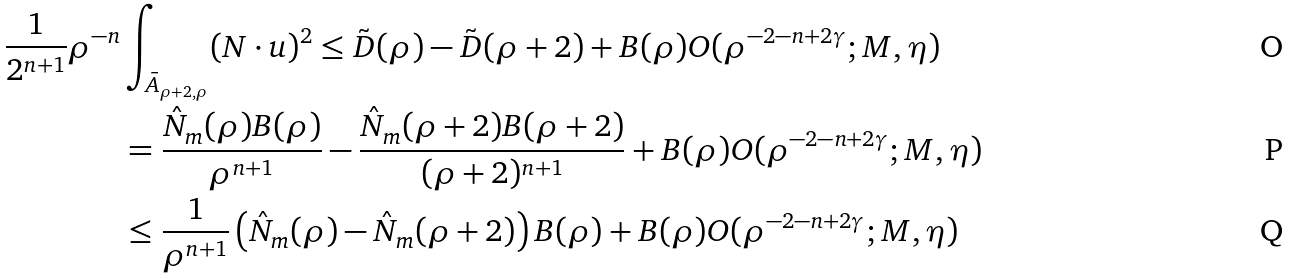Convert formula to latex. <formula><loc_0><loc_0><loc_500><loc_500>\frac { 1 } { 2 ^ { n + 1 } } \rho ^ { - n } & \int _ { \bar { A } _ { \rho + 2 , \rho } } ( N \cdot u ) ^ { 2 } \leq \tilde { D } ( \rho ) - \tilde { D } ( \rho + 2 ) + B ( \rho ) O ( \rho ^ { - 2 - n + 2 \gamma } ; M , \eta ) \\ & = \frac { \hat { N } _ { m } ( \rho ) B ( \rho ) } { \rho ^ { n + 1 } } - \frac { \hat { N } _ { m } ( \rho + 2 ) B ( \rho + 2 ) } { ( \rho + 2 ) ^ { n + 1 } } + B ( \rho ) O ( \rho ^ { - 2 - n + 2 \gamma } ; M , \eta ) \\ & \leq \frac { 1 } { \rho ^ { n + 1 } } \left ( \hat { N } _ { m } ( \rho ) - \hat { N } _ { m } ( \rho + 2 ) \right ) B ( \rho ) + B ( \rho ) O ( \rho ^ { - 2 - n + 2 \gamma } ; M , \eta )</formula> 